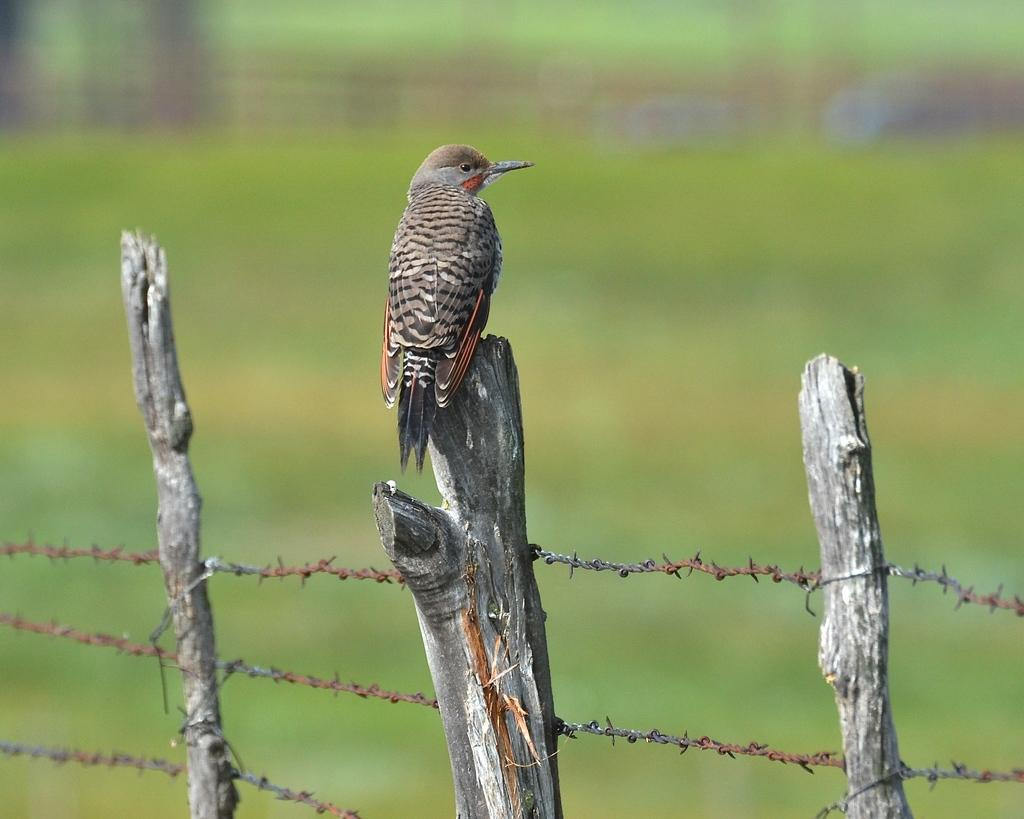What type of animal can be seen in the image? There is a bird in the image. Where is the bird located? The bird is standing on a tree branch. What is visible in the foreground of the image? There is a fence in the foreground of the image. How would you describe the background of the image? The background of the image is blurry. What type of locket is the bird wearing in the image? There is no locket present in the image; the bird is not wearing any jewelry. 